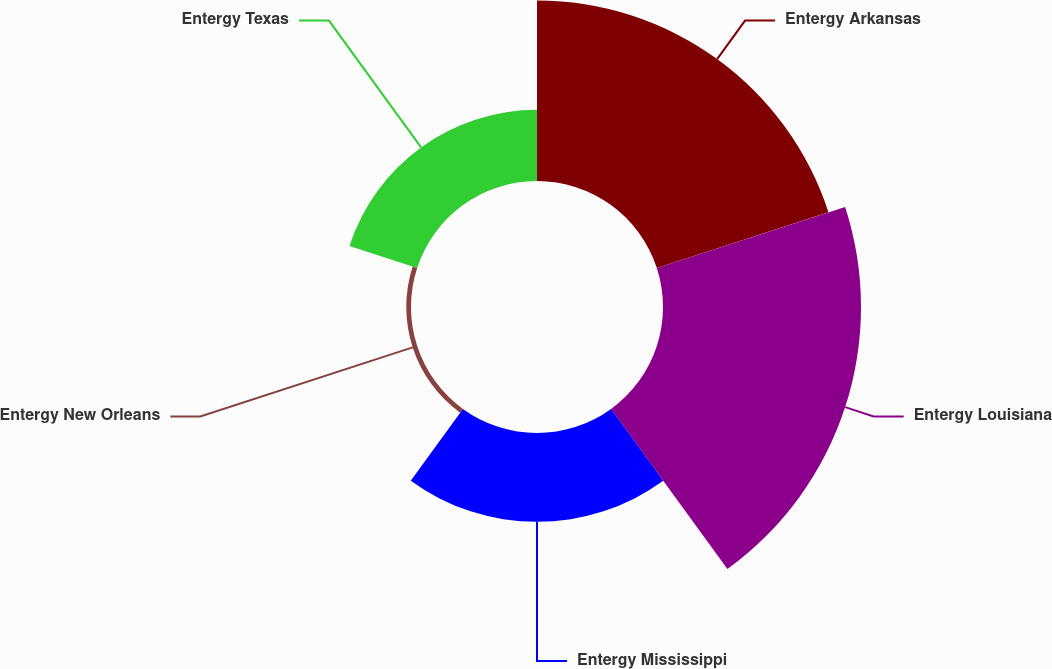<chart> <loc_0><loc_0><loc_500><loc_500><pie_chart><fcel>Entergy Arkansas<fcel>Entergy Louisiana<fcel>Entergy Mississippi<fcel>Entergy New Orleans<fcel>Entergy Texas<nl><fcel>33.22%<fcel>36.45%<fcel>16.35%<fcel>0.87%<fcel>13.11%<nl></chart> 